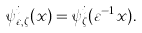Convert formula to latex. <formula><loc_0><loc_0><loc_500><loc_500>\psi _ { \varepsilon , \zeta } ^ { i } ( x ) = \psi _ { \zeta } ^ { i } ( \varepsilon ^ { - 1 } x ) .</formula> 